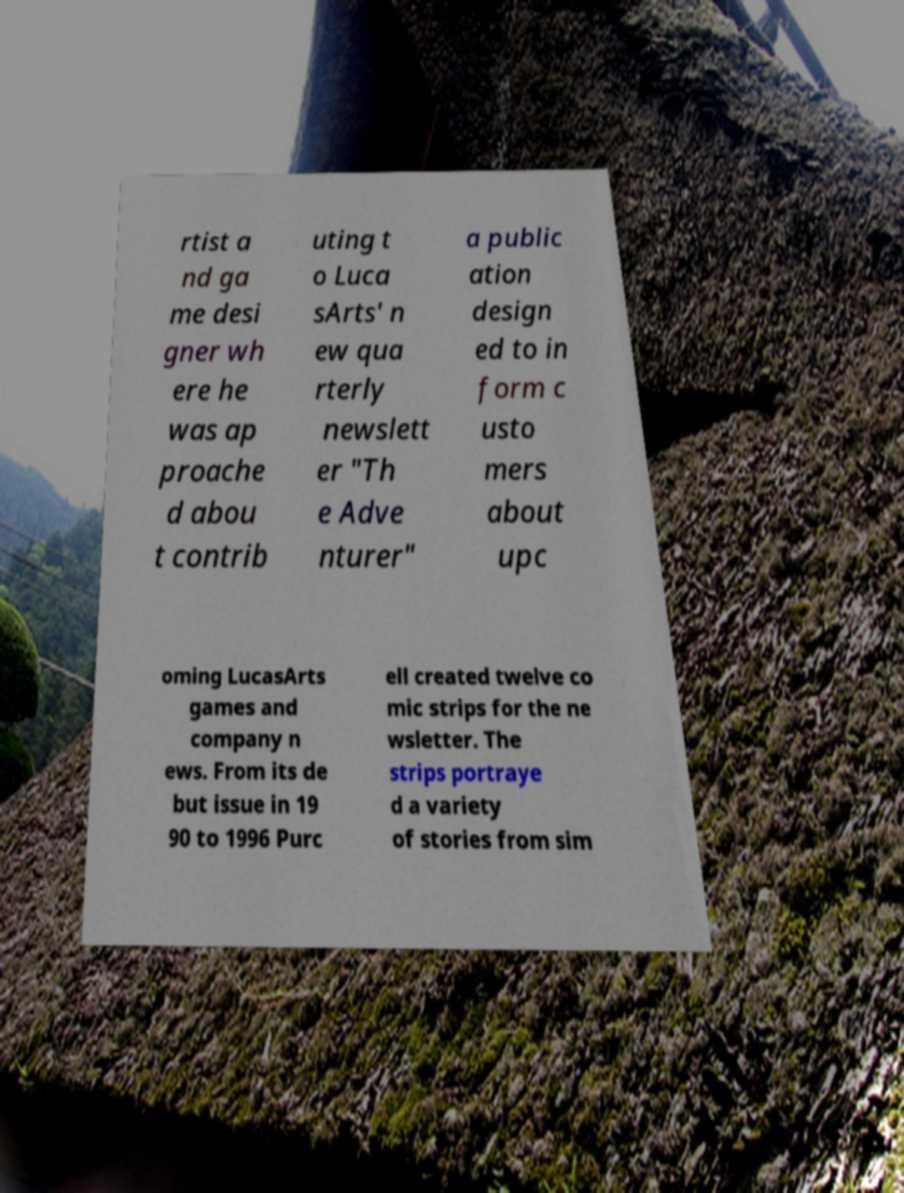Could you extract and type out the text from this image? rtist a nd ga me desi gner wh ere he was ap proache d abou t contrib uting t o Luca sArts' n ew qua rterly newslett er "Th e Adve nturer" a public ation design ed to in form c usto mers about upc oming LucasArts games and company n ews. From its de but issue in 19 90 to 1996 Purc ell created twelve co mic strips for the ne wsletter. The strips portraye d a variety of stories from sim 